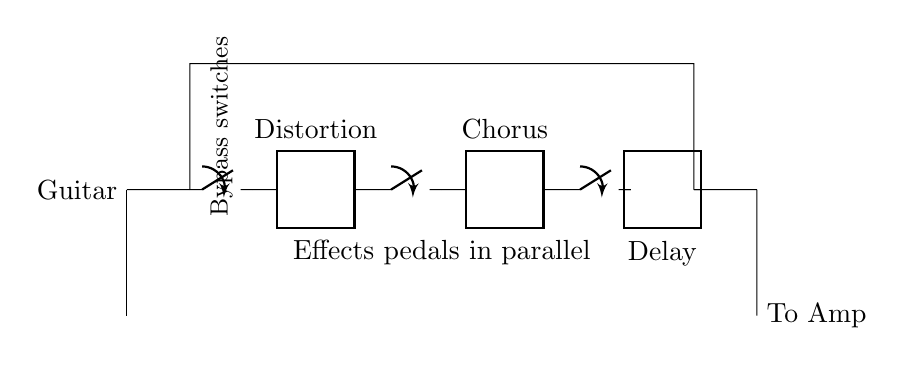What is the input device for this circuit? The input device connected to the circuit is labeled as "Guitar." It is indicated at the starting point of the diagram.
Answer: Guitar How many effect pedals are in this setup? There are three effect pedals connected in parallel as shown in the diagram. They are labeled as Distortion, Chorus, and Delay.
Answer: Three What do the switches in the circuit serve to do? The switches are used to bypass each effect pedal, allowing the signal to pass through without being altered by the effects when turned off. This function is labeled in the diagram.
Answer: Bypass What is the output destination for this circuit? The output destination is labeled as "To Amp," indicating that the processed signal will be sent to an amplifier.
Answer: To Amp Which effect pedal is placed between Distortion and Chorus? The effect pedal placed between Distortion and Chorus is not explicitly labeled, but visually and positionally, it is clear that there is no other pedal between them, confirming their adjacency.
Answer: None What is the configuration of the effect pedals? The configuration of the effect pedals is parallel, as indicated in the circuit, where each pedal receives the same input voltage directly from the guitar signal.
Answer: Parallel What would happen if one effect pedal is turned off? If one effect pedal is turned off using its corresponding bypass switch, the rest of the pedals would still remain active, allowing for different combinations of effects without interruption of the overall signal path.
Answer: Others remain active 